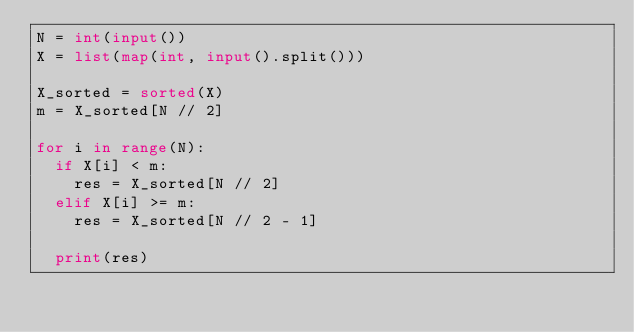Convert code to text. <code><loc_0><loc_0><loc_500><loc_500><_Python_>N = int(input())
X = list(map(int, input().split()))

X_sorted = sorted(X)
m = X_sorted[N // 2]

for i in range(N):
  if X[i] < m:
    res = X_sorted[N // 2]
  elif X[i] >= m:
    res = X_sorted[N // 2 - 1]

  print(res)
      </code> 